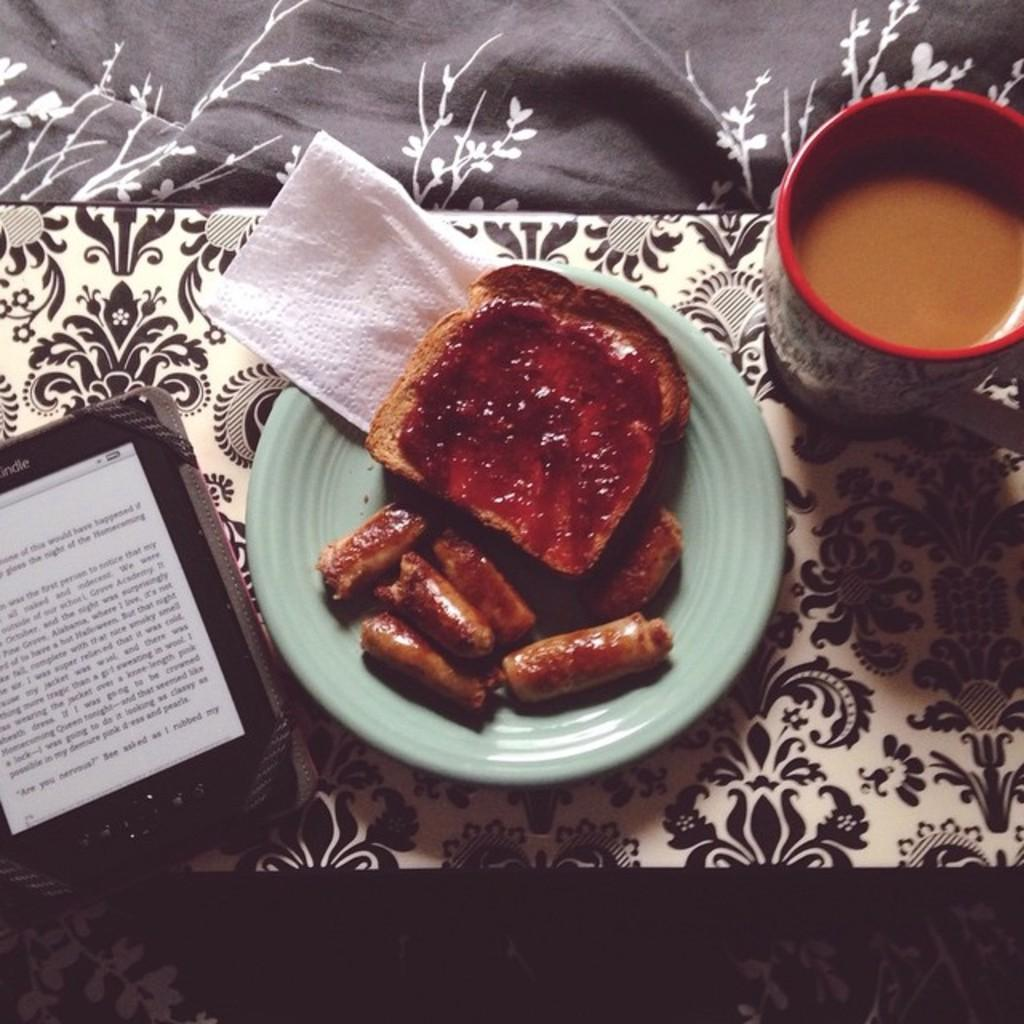<image>
Write a terse but informative summary of the picture. A Kindle device sits next to a plate of sausages and toast. 